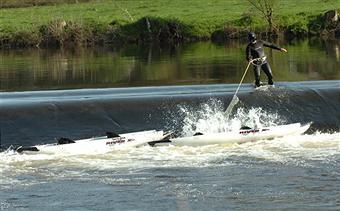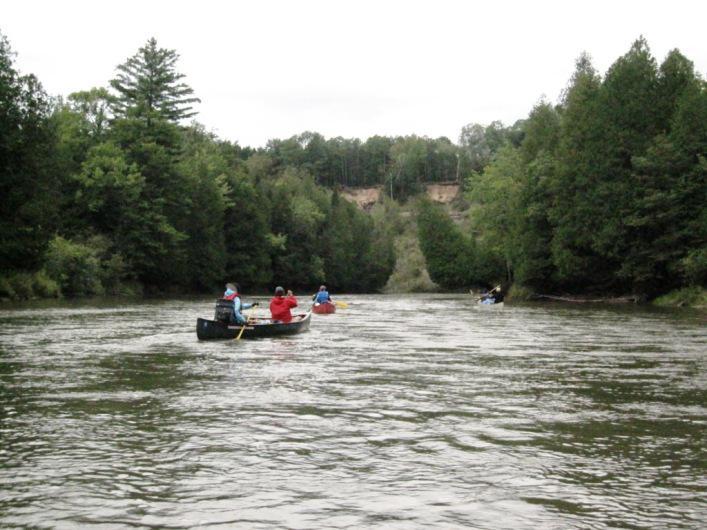The first image is the image on the left, the second image is the image on the right. Given the left and right images, does the statement "At least one image shows watercraft that is pulled up to the edge of the water." hold true? Answer yes or no. No. The first image is the image on the left, the second image is the image on the right. Analyze the images presented: Is the assertion "There are canoes sitting on the beach" valid? Answer yes or no. No. 